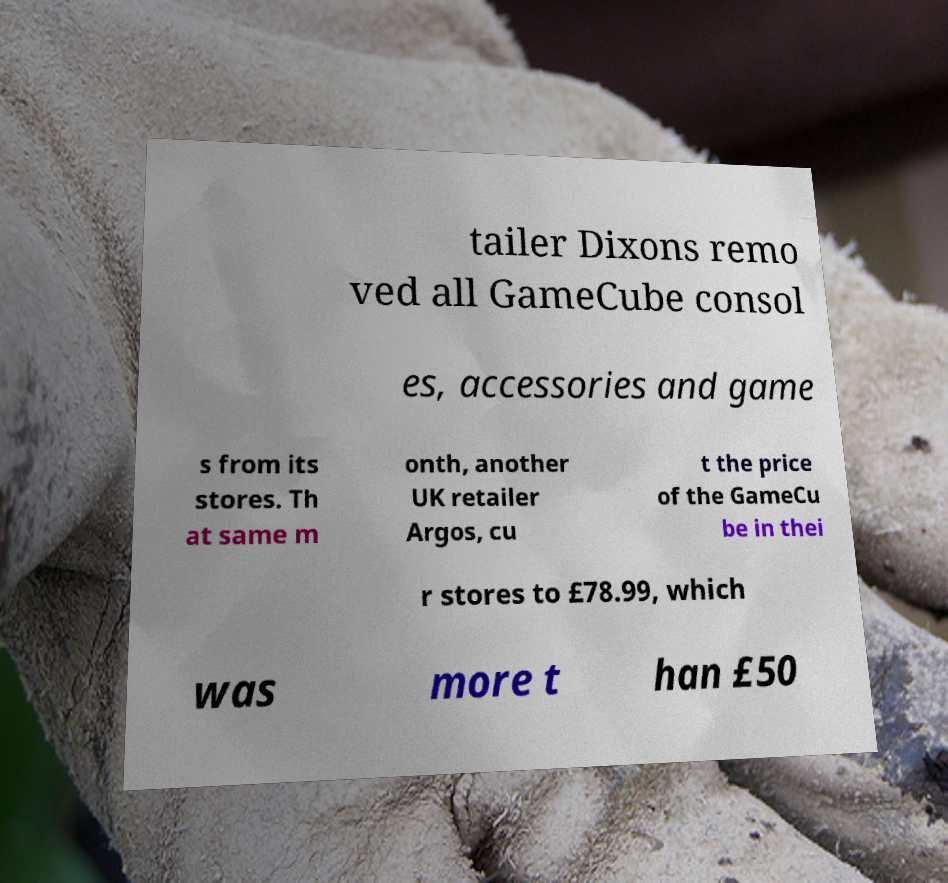Please identify and transcribe the text found in this image. tailer Dixons remo ved all GameCube consol es, accessories and game s from its stores. Th at same m onth, another UK retailer Argos, cu t the price of the GameCu be in thei r stores to £78.99, which was more t han £50 